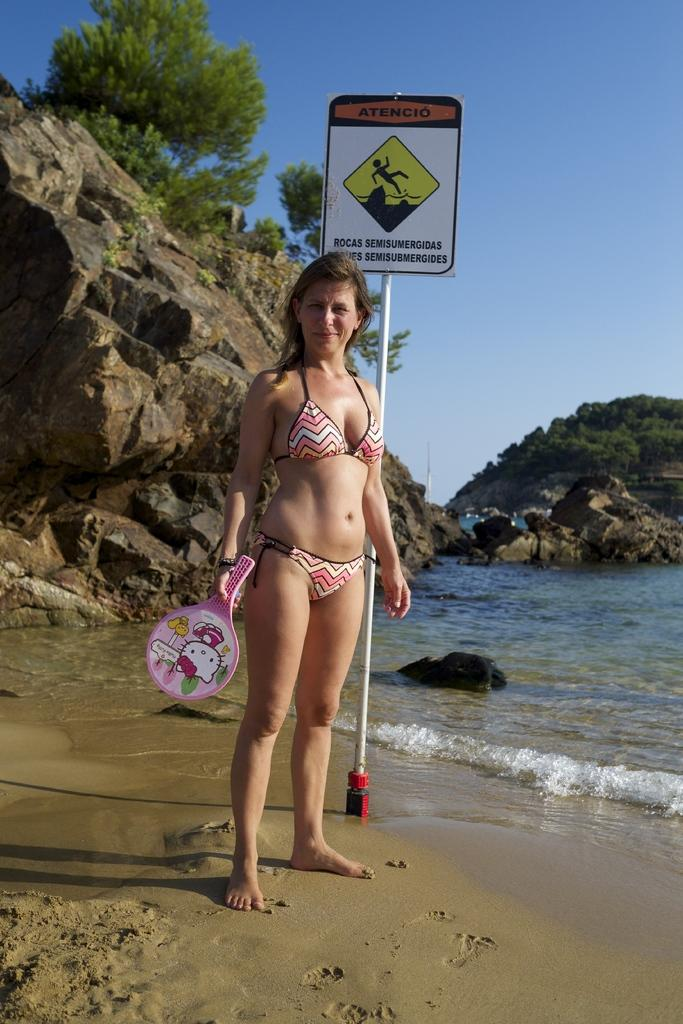Who is the main subject in the image? There is a girl in the image. What is the girl holding in the image? The girl is holding a bat. Where is the girl standing in the image? The girl is standing on the sand. What can be seen on a pole in the image? There is a board on a pole in the image. What natural feature is visible in the image? The sea is visible in the image. What type of landscape can be seen in the background of the image? There is a rock mountain with trees in the image. How many lizards are crawling on the girl's bat in the image? There are no lizards present in the image, so it is not possible to determine how many might be crawling on the bat. 